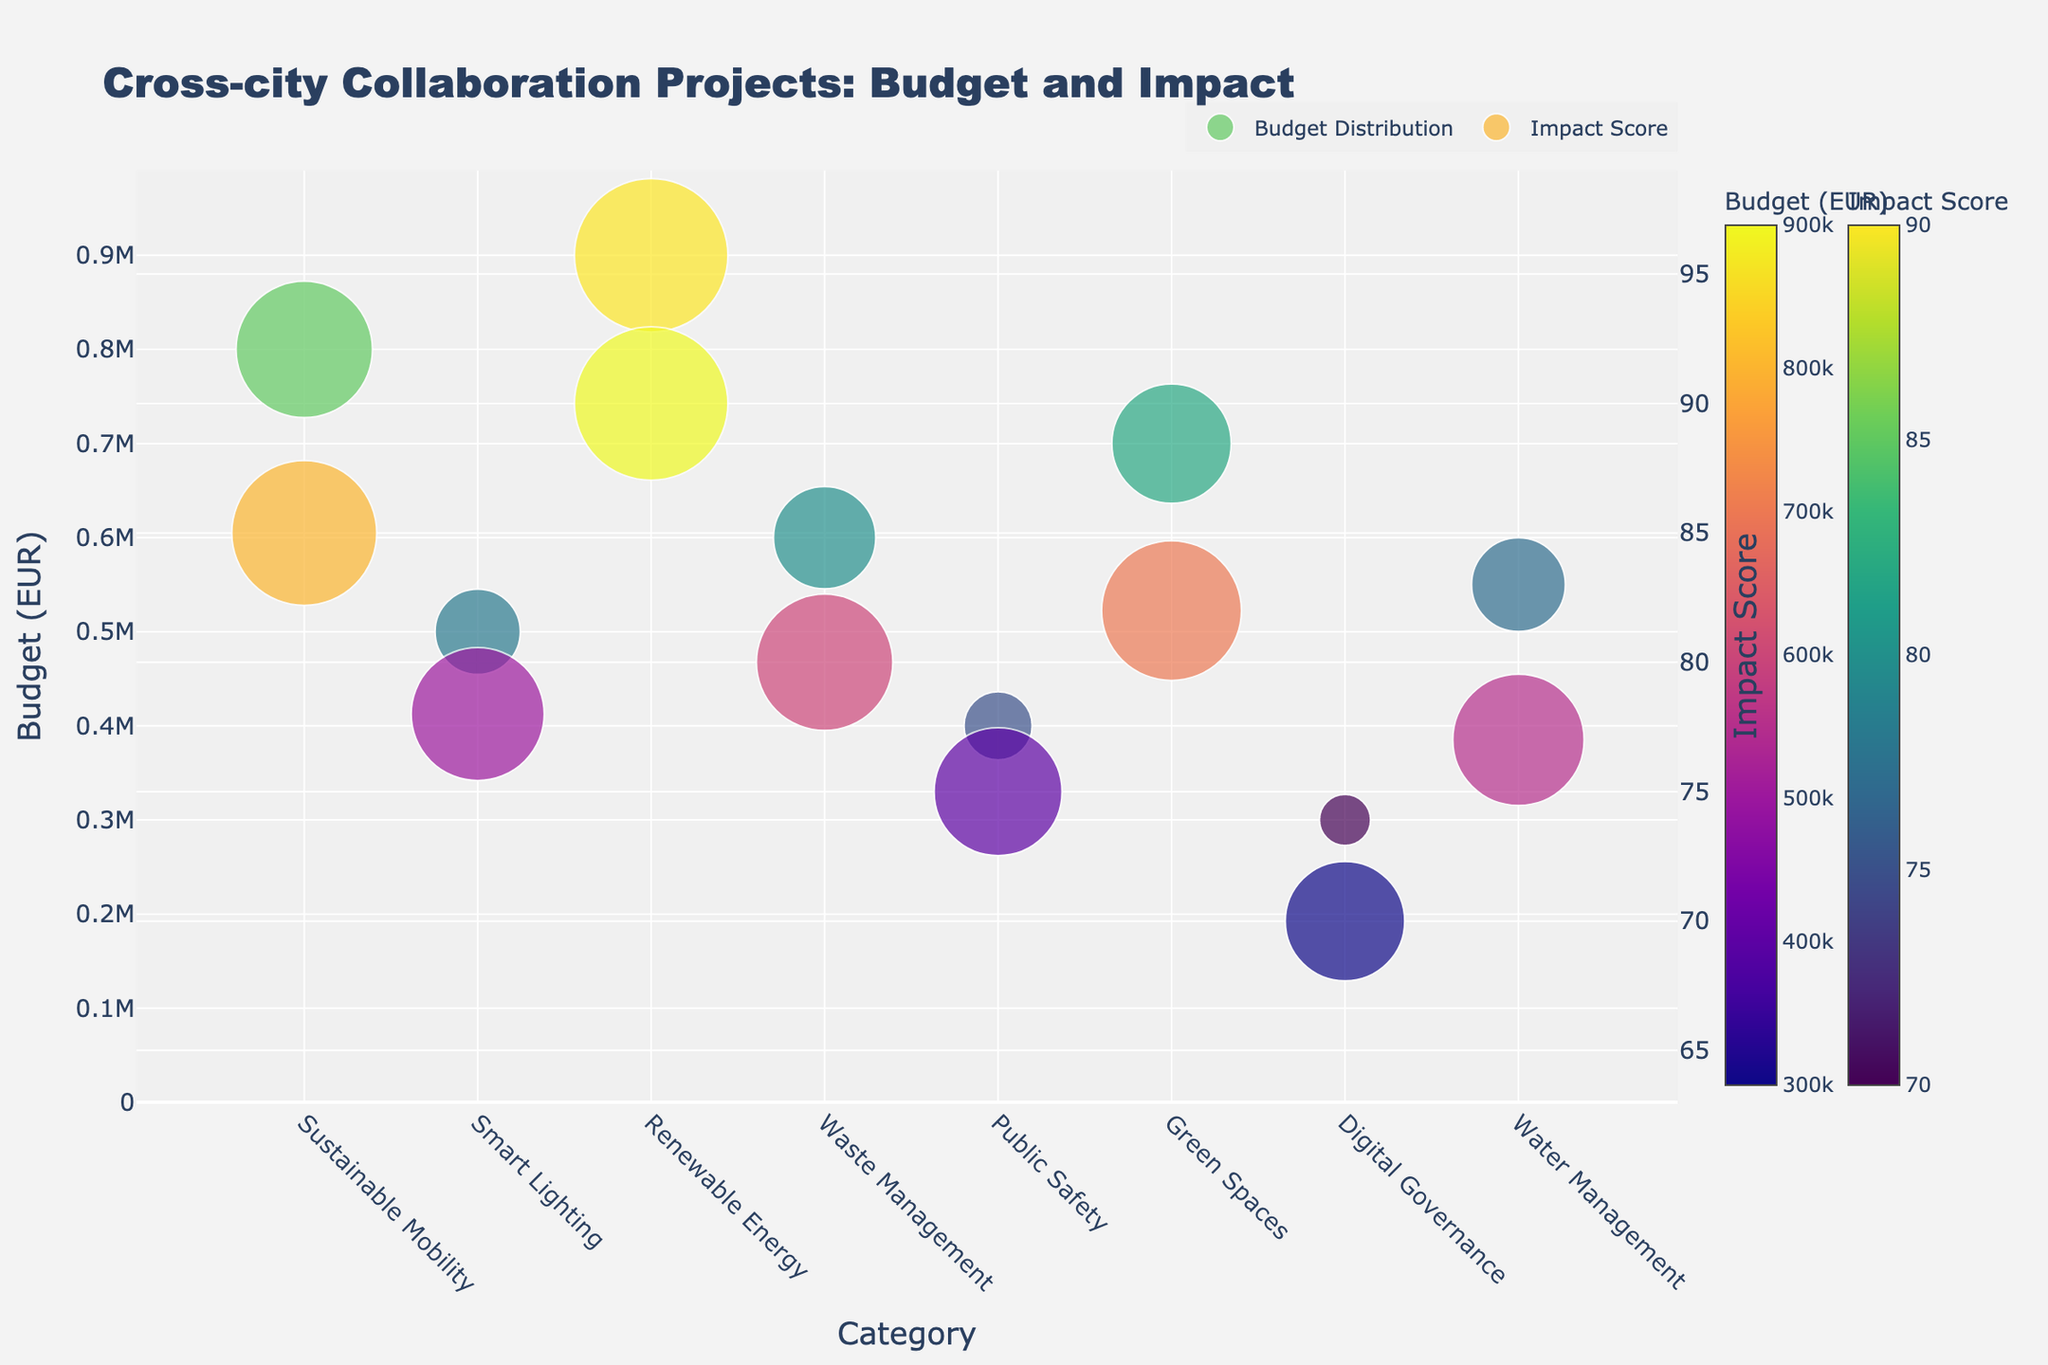What's the title of the figure? The title of the figure is prominently displayed at the top of the plot, stating the general subject of the visual data.
Answer: Cross-city Collaboration Projects: Budget and Impact How many categories of projects are represented in the plot? By counting the unique values on the x-axis, which represents categories, we identify the number of different types of projects. There are 8 categories visible on the x-axis.
Answer: 8 Which project has the highest budget? To find the project with the highest budget, we look for the largest bubble (in terms of size) in the Budget Distribution subplot. The Urban Solar Initiative, with a budget of €900,000, is the largest bubble.
Answer: Urban Solar Initiative Which category shows the highest impact score on average? We need to visually estimate the average impact score for each category displayed on the right y-axis in the Impact Score subplot. Renewable Energy has the highest impact score of 90, which seems to be the highest average.
Answer: Renewable Energy How many projects have an impact score above 80? By examining the color and position of bubbles along the y2 axis (Impact Score), we count the number of bubbles placed above the score of 80. There are 4 projects with impact scores above 80.
Answer: 4 What's the total budget of projects in the Waste Management category? There is only one project in the Waste Management category in the plot, Smart Waste Collection. Therefore, the total budget is just for this project, summing to €600,000.
Answer: €600,000 Which project has the smallest bubble size, indicating the lowest budget, in the Budget Distribution subplot? The smallest bubble size in the Budget Distribution subplot represents the lowest budget amount. The Citizen Engagement Platform with a budget of €300,000 has the smallest bubble.
Answer: Citizen Engagement Platform Is there any correlation between the budget size and impact score? To establish a correlation, observe if there's a pattern linking the size of bubbles on the Budget subplot to the color intensity (Impact Score). Since the largest budget has a high impact score and lower budgets have moderate to low impact scores, there is a positive correlation.
Answer: Yes In the Digital Governance category, what is the budget and impact score? By locating the Digital Governance bubble on the plot and checking its size and color bar, we identify its budget and impact score from the respective scales. The budget is €300,000 and the impact score is 70.
Answer: €300,000, 70 Which project in the figure is related to Water Management, and what's its budget? Locate the Water Management category and identify the corresponding bubble, finding the budget from the bubble's size. The Smart Water Sensors project has a budget of €550,000.
Answer: Smart Water Sensors, €550,000 